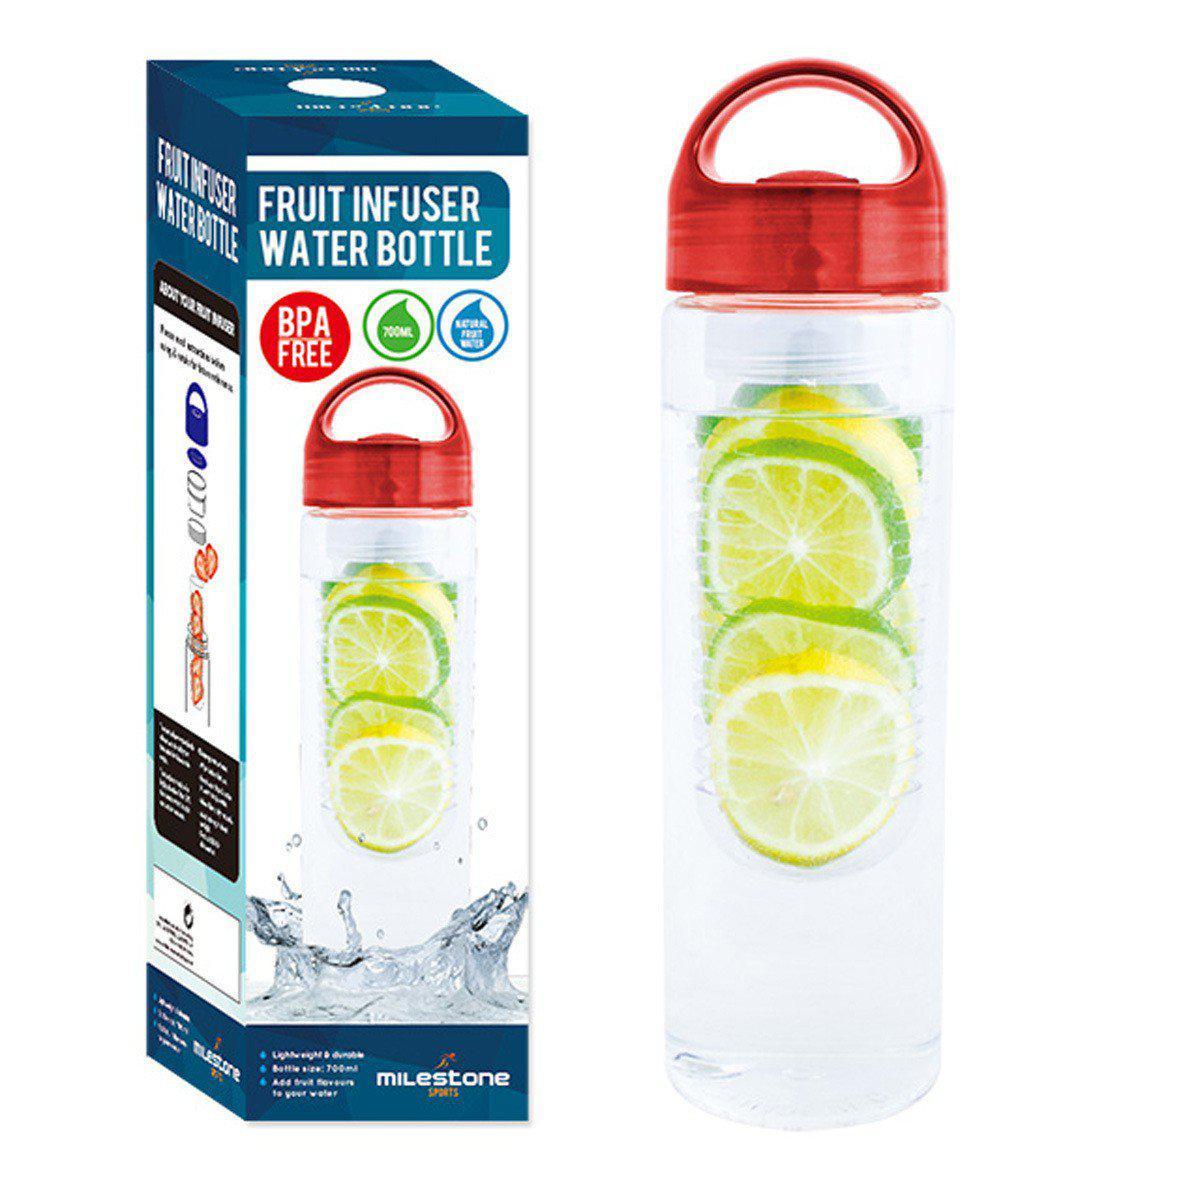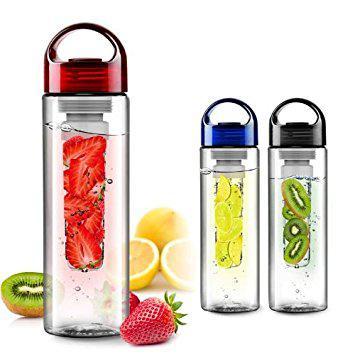The first image is the image on the left, the second image is the image on the right. Considering the images on both sides, is "There are fruits near the glasses in one of the images." valid? Answer yes or no. Yes. 